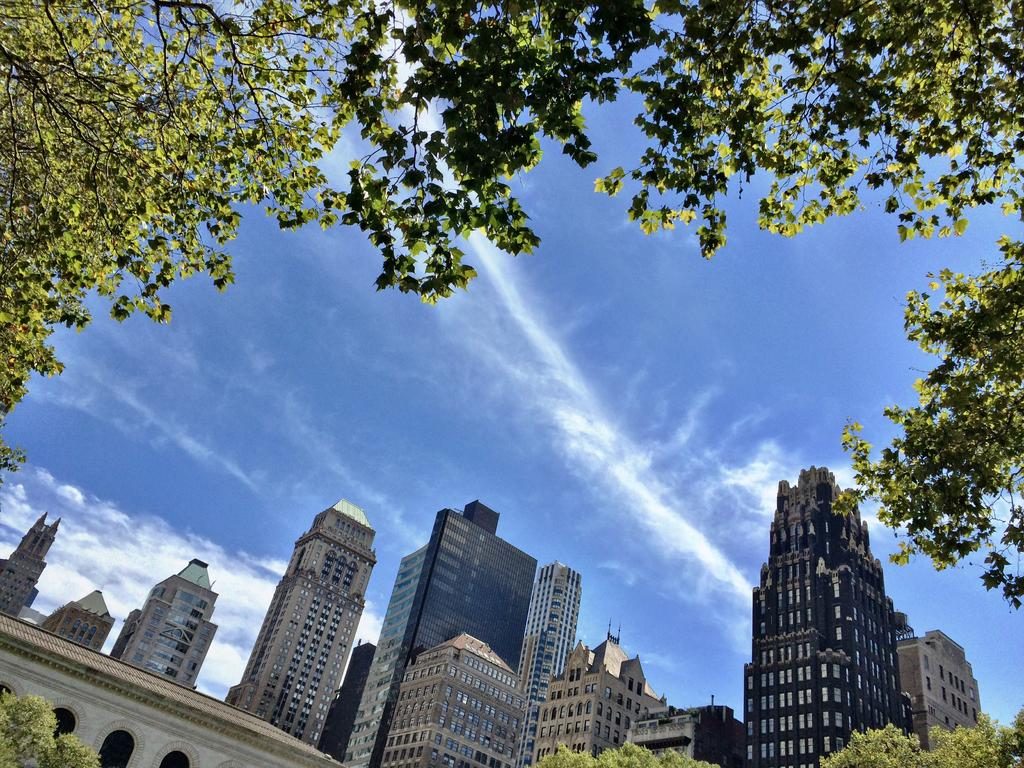What type of structures can be seen in the image? There are buildings in the image. What feature is visible on the buildings? There are windows visible in the image. What type of vegetation is present in the image? There are trees and plants in the image. What part of the natural environment is visible in the image? The sky is visible in the image. What type of brass instrument is being played in the image? There is no brass instrument or any indication of music being played in the image. 